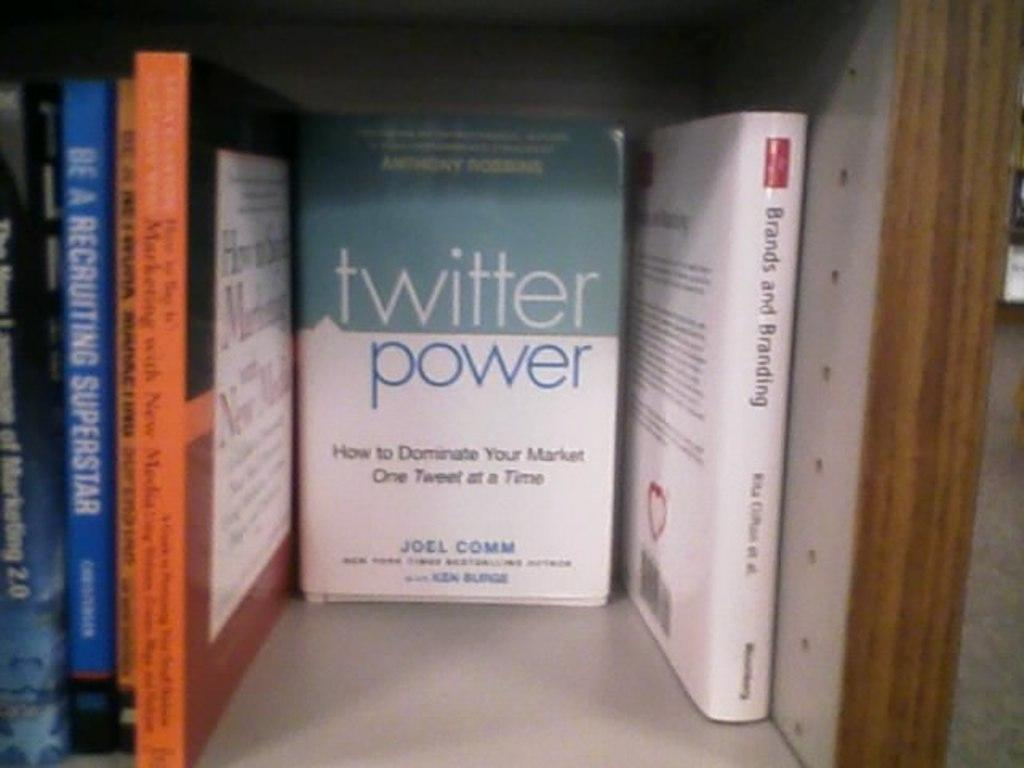Provide a one-sentence caption for the provided image. A book shelf with books such as twitter power by Joel Comm. 